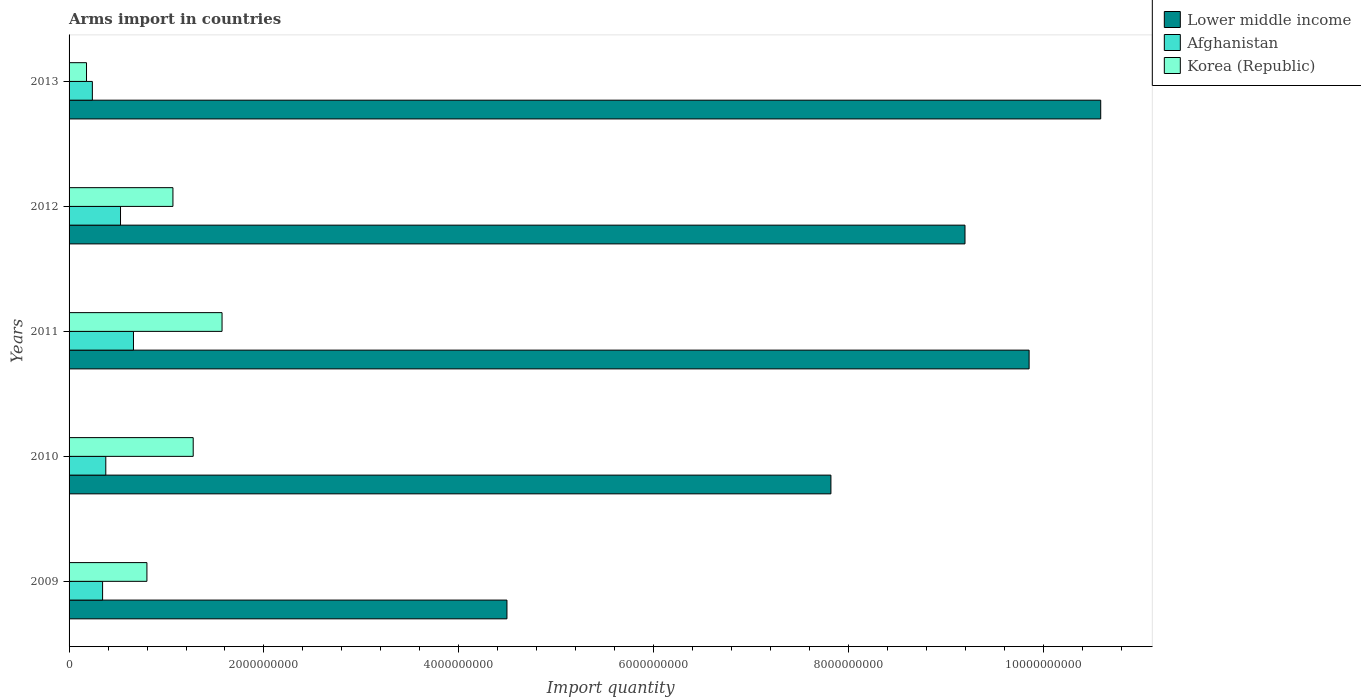How many groups of bars are there?
Keep it short and to the point. 5. Are the number of bars on each tick of the Y-axis equal?
Your answer should be compact. Yes. In how many cases, is the number of bars for a given year not equal to the number of legend labels?
Provide a short and direct response. 0. What is the total arms import in Korea (Republic) in 2010?
Ensure brevity in your answer.  1.27e+09. Across all years, what is the maximum total arms import in Afghanistan?
Make the answer very short. 6.61e+08. Across all years, what is the minimum total arms import in Korea (Republic)?
Offer a terse response. 1.79e+08. In which year was the total arms import in Afghanistan minimum?
Offer a very short reply. 2013. What is the total total arms import in Lower middle income in the graph?
Your answer should be very brief. 4.19e+1. What is the difference between the total arms import in Korea (Republic) in 2010 and that in 2012?
Give a very brief answer. 2.08e+08. What is the difference between the total arms import in Afghanistan in 2010 and the total arms import in Lower middle income in 2013?
Offer a terse response. -1.02e+1. What is the average total arms import in Lower middle income per year?
Your answer should be compact. 8.39e+09. In the year 2012, what is the difference between the total arms import in Lower middle income and total arms import in Afghanistan?
Your answer should be compact. 8.67e+09. What is the ratio of the total arms import in Lower middle income in 2009 to that in 2010?
Make the answer very short. 0.57. What is the difference between the highest and the second highest total arms import in Lower middle income?
Make the answer very short. 7.35e+08. What is the difference between the highest and the lowest total arms import in Afghanistan?
Keep it short and to the point. 4.22e+08. In how many years, is the total arms import in Korea (Republic) greater than the average total arms import in Korea (Republic) taken over all years?
Provide a short and direct response. 3. Is the sum of the total arms import in Korea (Republic) in 2011 and 2013 greater than the maximum total arms import in Lower middle income across all years?
Your answer should be compact. No. What does the 3rd bar from the top in 2010 represents?
Your response must be concise. Lower middle income. What does the 2nd bar from the bottom in 2009 represents?
Make the answer very short. Afghanistan. Is it the case that in every year, the sum of the total arms import in Afghanistan and total arms import in Lower middle income is greater than the total arms import in Korea (Republic)?
Ensure brevity in your answer.  Yes. Does the graph contain grids?
Your answer should be very brief. No. Where does the legend appear in the graph?
Provide a short and direct response. Top right. What is the title of the graph?
Provide a succinct answer. Arms import in countries. What is the label or title of the X-axis?
Ensure brevity in your answer.  Import quantity. What is the Import quantity of Lower middle income in 2009?
Ensure brevity in your answer.  4.49e+09. What is the Import quantity of Afghanistan in 2009?
Provide a succinct answer. 3.44e+08. What is the Import quantity in Korea (Republic) in 2009?
Make the answer very short. 7.99e+08. What is the Import quantity of Lower middle income in 2010?
Your answer should be very brief. 7.82e+09. What is the Import quantity in Afghanistan in 2010?
Provide a short and direct response. 3.77e+08. What is the Import quantity of Korea (Republic) in 2010?
Your response must be concise. 1.27e+09. What is the Import quantity in Lower middle income in 2011?
Ensure brevity in your answer.  9.85e+09. What is the Import quantity of Afghanistan in 2011?
Ensure brevity in your answer.  6.61e+08. What is the Import quantity of Korea (Republic) in 2011?
Ensure brevity in your answer.  1.57e+09. What is the Import quantity of Lower middle income in 2012?
Provide a short and direct response. 9.20e+09. What is the Import quantity of Afghanistan in 2012?
Offer a very short reply. 5.28e+08. What is the Import quantity in Korea (Republic) in 2012?
Provide a short and direct response. 1.07e+09. What is the Import quantity in Lower middle income in 2013?
Ensure brevity in your answer.  1.06e+1. What is the Import quantity in Afghanistan in 2013?
Keep it short and to the point. 2.39e+08. What is the Import quantity of Korea (Republic) in 2013?
Provide a succinct answer. 1.79e+08. Across all years, what is the maximum Import quantity in Lower middle income?
Your answer should be compact. 1.06e+1. Across all years, what is the maximum Import quantity in Afghanistan?
Provide a short and direct response. 6.61e+08. Across all years, what is the maximum Import quantity of Korea (Republic)?
Ensure brevity in your answer.  1.57e+09. Across all years, what is the minimum Import quantity of Lower middle income?
Offer a terse response. 4.49e+09. Across all years, what is the minimum Import quantity of Afghanistan?
Offer a very short reply. 2.39e+08. Across all years, what is the minimum Import quantity of Korea (Republic)?
Provide a short and direct response. 1.79e+08. What is the total Import quantity in Lower middle income in the graph?
Make the answer very short. 4.19e+1. What is the total Import quantity of Afghanistan in the graph?
Your answer should be very brief. 2.15e+09. What is the total Import quantity in Korea (Republic) in the graph?
Provide a short and direct response. 4.89e+09. What is the difference between the Import quantity in Lower middle income in 2009 and that in 2010?
Offer a very short reply. -3.32e+09. What is the difference between the Import quantity in Afghanistan in 2009 and that in 2010?
Give a very brief answer. -3.30e+07. What is the difference between the Import quantity of Korea (Republic) in 2009 and that in 2010?
Provide a short and direct response. -4.75e+08. What is the difference between the Import quantity in Lower middle income in 2009 and that in 2011?
Make the answer very short. -5.36e+09. What is the difference between the Import quantity in Afghanistan in 2009 and that in 2011?
Offer a terse response. -3.17e+08. What is the difference between the Import quantity in Korea (Republic) in 2009 and that in 2011?
Give a very brief answer. -7.71e+08. What is the difference between the Import quantity of Lower middle income in 2009 and that in 2012?
Offer a terse response. -4.70e+09. What is the difference between the Import quantity in Afghanistan in 2009 and that in 2012?
Make the answer very short. -1.84e+08. What is the difference between the Import quantity of Korea (Republic) in 2009 and that in 2012?
Keep it short and to the point. -2.67e+08. What is the difference between the Import quantity of Lower middle income in 2009 and that in 2013?
Provide a succinct answer. -6.09e+09. What is the difference between the Import quantity of Afghanistan in 2009 and that in 2013?
Offer a terse response. 1.05e+08. What is the difference between the Import quantity of Korea (Republic) in 2009 and that in 2013?
Your answer should be very brief. 6.20e+08. What is the difference between the Import quantity in Lower middle income in 2010 and that in 2011?
Make the answer very short. -2.03e+09. What is the difference between the Import quantity in Afghanistan in 2010 and that in 2011?
Keep it short and to the point. -2.84e+08. What is the difference between the Import quantity in Korea (Republic) in 2010 and that in 2011?
Provide a short and direct response. -2.96e+08. What is the difference between the Import quantity in Lower middle income in 2010 and that in 2012?
Your answer should be very brief. -1.38e+09. What is the difference between the Import quantity in Afghanistan in 2010 and that in 2012?
Give a very brief answer. -1.51e+08. What is the difference between the Import quantity of Korea (Republic) in 2010 and that in 2012?
Your answer should be very brief. 2.08e+08. What is the difference between the Import quantity of Lower middle income in 2010 and that in 2013?
Make the answer very short. -2.77e+09. What is the difference between the Import quantity of Afghanistan in 2010 and that in 2013?
Provide a succinct answer. 1.38e+08. What is the difference between the Import quantity of Korea (Republic) in 2010 and that in 2013?
Provide a short and direct response. 1.10e+09. What is the difference between the Import quantity in Lower middle income in 2011 and that in 2012?
Keep it short and to the point. 6.58e+08. What is the difference between the Import quantity in Afghanistan in 2011 and that in 2012?
Your answer should be very brief. 1.33e+08. What is the difference between the Import quantity of Korea (Republic) in 2011 and that in 2012?
Keep it short and to the point. 5.04e+08. What is the difference between the Import quantity of Lower middle income in 2011 and that in 2013?
Offer a very short reply. -7.35e+08. What is the difference between the Import quantity of Afghanistan in 2011 and that in 2013?
Make the answer very short. 4.22e+08. What is the difference between the Import quantity of Korea (Republic) in 2011 and that in 2013?
Provide a short and direct response. 1.39e+09. What is the difference between the Import quantity of Lower middle income in 2012 and that in 2013?
Keep it short and to the point. -1.39e+09. What is the difference between the Import quantity in Afghanistan in 2012 and that in 2013?
Offer a terse response. 2.89e+08. What is the difference between the Import quantity in Korea (Republic) in 2012 and that in 2013?
Ensure brevity in your answer.  8.87e+08. What is the difference between the Import quantity in Lower middle income in 2009 and the Import quantity in Afghanistan in 2010?
Offer a very short reply. 4.12e+09. What is the difference between the Import quantity of Lower middle income in 2009 and the Import quantity of Korea (Republic) in 2010?
Give a very brief answer. 3.22e+09. What is the difference between the Import quantity in Afghanistan in 2009 and the Import quantity in Korea (Republic) in 2010?
Your response must be concise. -9.30e+08. What is the difference between the Import quantity in Lower middle income in 2009 and the Import quantity in Afghanistan in 2011?
Your response must be concise. 3.83e+09. What is the difference between the Import quantity in Lower middle income in 2009 and the Import quantity in Korea (Republic) in 2011?
Provide a succinct answer. 2.92e+09. What is the difference between the Import quantity in Afghanistan in 2009 and the Import quantity in Korea (Republic) in 2011?
Your answer should be compact. -1.23e+09. What is the difference between the Import quantity of Lower middle income in 2009 and the Import quantity of Afghanistan in 2012?
Your answer should be compact. 3.97e+09. What is the difference between the Import quantity of Lower middle income in 2009 and the Import quantity of Korea (Republic) in 2012?
Ensure brevity in your answer.  3.43e+09. What is the difference between the Import quantity in Afghanistan in 2009 and the Import quantity in Korea (Republic) in 2012?
Give a very brief answer. -7.22e+08. What is the difference between the Import quantity of Lower middle income in 2009 and the Import quantity of Afghanistan in 2013?
Your answer should be compact. 4.26e+09. What is the difference between the Import quantity in Lower middle income in 2009 and the Import quantity in Korea (Republic) in 2013?
Keep it short and to the point. 4.32e+09. What is the difference between the Import quantity in Afghanistan in 2009 and the Import quantity in Korea (Republic) in 2013?
Your answer should be very brief. 1.65e+08. What is the difference between the Import quantity of Lower middle income in 2010 and the Import quantity of Afghanistan in 2011?
Your answer should be very brief. 7.16e+09. What is the difference between the Import quantity in Lower middle income in 2010 and the Import quantity in Korea (Republic) in 2011?
Keep it short and to the point. 6.25e+09. What is the difference between the Import quantity in Afghanistan in 2010 and the Import quantity in Korea (Republic) in 2011?
Ensure brevity in your answer.  -1.19e+09. What is the difference between the Import quantity of Lower middle income in 2010 and the Import quantity of Afghanistan in 2012?
Make the answer very short. 7.29e+09. What is the difference between the Import quantity of Lower middle income in 2010 and the Import quantity of Korea (Republic) in 2012?
Provide a succinct answer. 6.75e+09. What is the difference between the Import quantity in Afghanistan in 2010 and the Import quantity in Korea (Republic) in 2012?
Your answer should be compact. -6.89e+08. What is the difference between the Import quantity of Lower middle income in 2010 and the Import quantity of Afghanistan in 2013?
Offer a very short reply. 7.58e+09. What is the difference between the Import quantity of Lower middle income in 2010 and the Import quantity of Korea (Republic) in 2013?
Your answer should be compact. 7.64e+09. What is the difference between the Import quantity in Afghanistan in 2010 and the Import quantity in Korea (Republic) in 2013?
Make the answer very short. 1.98e+08. What is the difference between the Import quantity of Lower middle income in 2011 and the Import quantity of Afghanistan in 2012?
Your answer should be compact. 9.32e+09. What is the difference between the Import quantity of Lower middle income in 2011 and the Import quantity of Korea (Republic) in 2012?
Offer a very short reply. 8.79e+09. What is the difference between the Import quantity in Afghanistan in 2011 and the Import quantity in Korea (Republic) in 2012?
Give a very brief answer. -4.05e+08. What is the difference between the Import quantity in Lower middle income in 2011 and the Import quantity in Afghanistan in 2013?
Make the answer very short. 9.61e+09. What is the difference between the Import quantity of Lower middle income in 2011 and the Import quantity of Korea (Republic) in 2013?
Ensure brevity in your answer.  9.67e+09. What is the difference between the Import quantity of Afghanistan in 2011 and the Import quantity of Korea (Republic) in 2013?
Give a very brief answer. 4.82e+08. What is the difference between the Import quantity of Lower middle income in 2012 and the Import quantity of Afghanistan in 2013?
Your response must be concise. 8.96e+09. What is the difference between the Import quantity in Lower middle income in 2012 and the Import quantity in Korea (Republic) in 2013?
Offer a very short reply. 9.02e+09. What is the difference between the Import quantity in Afghanistan in 2012 and the Import quantity in Korea (Republic) in 2013?
Offer a very short reply. 3.49e+08. What is the average Import quantity of Lower middle income per year?
Offer a terse response. 8.39e+09. What is the average Import quantity in Afghanistan per year?
Your response must be concise. 4.30e+08. What is the average Import quantity of Korea (Republic) per year?
Keep it short and to the point. 9.78e+08. In the year 2009, what is the difference between the Import quantity of Lower middle income and Import quantity of Afghanistan?
Your answer should be very brief. 4.15e+09. In the year 2009, what is the difference between the Import quantity in Lower middle income and Import quantity in Korea (Republic)?
Ensure brevity in your answer.  3.70e+09. In the year 2009, what is the difference between the Import quantity in Afghanistan and Import quantity in Korea (Republic)?
Keep it short and to the point. -4.55e+08. In the year 2010, what is the difference between the Import quantity of Lower middle income and Import quantity of Afghanistan?
Provide a short and direct response. 7.44e+09. In the year 2010, what is the difference between the Import quantity in Lower middle income and Import quantity in Korea (Republic)?
Provide a short and direct response. 6.54e+09. In the year 2010, what is the difference between the Import quantity of Afghanistan and Import quantity of Korea (Republic)?
Your answer should be compact. -8.97e+08. In the year 2011, what is the difference between the Import quantity in Lower middle income and Import quantity in Afghanistan?
Make the answer very short. 9.19e+09. In the year 2011, what is the difference between the Import quantity of Lower middle income and Import quantity of Korea (Republic)?
Provide a short and direct response. 8.28e+09. In the year 2011, what is the difference between the Import quantity of Afghanistan and Import quantity of Korea (Republic)?
Ensure brevity in your answer.  -9.09e+08. In the year 2012, what is the difference between the Import quantity in Lower middle income and Import quantity in Afghanistan?
Offer a very short reply. 8.67e+09. In the year 2012, what is the difference between the Import quantity of Lower middle income and Import quantity of Korea (Republic)?
Keep it short and to the point. 8.13e+09. In the year 2012, what is the difference between the Import quantity in Afghanistan and Import quantity in Korea (Republic)?
Your answer should be very brief. -5.38e+08. In the year 2013, what is the difference between the Import quantity in Lower middle income and Import quantity in Afghanistan?
Ensure brevity in your answer.  1.03e+1. In the year 2013, what is the difference between the Import quantity of Lower middle income and Import quantity of Korea (Republic)?
Make the answer very short. 1.04e+1. In the year 2013, what is the difference between the Import quantity in Afghanistan and Import quantity in Korea (Republic)?
Ensure brevity in your answer.  6.00e+07. What is the ratio of the Import quantity of Lower middle income in 2009 to that in 2010?
Give a very brief answer. 0.57. What is the ratio of the Import quantity of Afghanistan in 2009 to that in 2010?
Ensure brevity in your answer.  0.91. What is the ratio of the Import quantity of Korea (Republic) in 2009 to that in 2010?
Your response must be concise. 0.63. What is the ratio of the Import quantity in Lower middle income in 2009 to that in 2011?
Ensure brevity in your answer.  0.46. What is the ratio of the Import quantity of Afghanistan in 2009 to that in 2011?
Your answer should be very brief. 0.52. What is the ratio of the Import quantity in Korea (Republic) in 2009 to that in 2011?
Your answer should be compact. 0.51. What is the ratio of the Import quantity in Lower middle income in 2009 to that in 2012?
Offer a terse response. 0.49. What is the ratio of the Import quantity of Afghanistan in 2009 to that in 2012?
Give a very brief answer. 0.65. What is the ratio of the Import quantity in Korea (Republic) in 2009 to that in 2012?
Your answer should be very brief. 0.75. What is the ratio of the Import quantity of Lower middle income in 2009 to that in 2013?
Offer a terse response. 0.42. What is the ratio of the Import quantity in Afghanistan in 2009 to that in 2013?
Make the answer very short. 1.44. What is the ratio of the Import quantity in Korea (Republic) in 2009 to that in 2013?
Provide a short and direct response. 4.46. What is the ratio of the Import quantity in Lower middle income in 2010 to that in 2011?
Your response must be concise. 0.79. What is the ratio of the Import quantity of Afghanistan in 2010 to that in 2011?
Your answer should be very brief. 0.57. What is the ratio of the Import quantity in Korea (Republic) in 2010 to that in 2011?
Your answer should be very brief. 0.81. What is the ratio of the Import quantity in Lower middle income in 2010 to that in 2012?
Keep it short and to the point. 0.85. What is the ratio of the Import quantity in Afghanistan in 2010 to that in 2012?
Your response must be concise. 0.71. What is the ratio of the Import quantity in Korea (Republic) in 2010 to that in 2012?
Offer a terse response. 1.2. What is the ratio of the Import quantity of Lower middle income in 2010 to that in 2013?
Your response must be concise. 0.74. What is the ratio of the Import quantity in Afghanistan in 2010 to that in 2013?
Your answer should be compact. 1.58. What is the ratio of the Import quantity of Korea (Republic) in 2010 to that in 2013?
Offer a terse response. 7.12. What is the ratio of the Import quantity in Lower middle income in 2011 to that in 2012?
Offer a terse response. 1.07. What is the ratio of the Import quantity in Afghanistan in 2011 to that in 2012?
Your answer should be very brief. 1.25. What is the ratio of the Import quantity in Korea (Republic) in 2011 to that in 2012?
Provide a short and direct response. 1.47. What is the ratio of the Import quantity of Lower middle income in 2011 to that in 2013?
Make the answer very short. 0.93. What is the ratio of the Import quantity in Afghanistan in 2011 to that in 2013?
Offer a terse response. 2.77. What is the ratio of the Import quantity of Korea (Republic) in 2011 to that in 2013?
Provide a short and direct response. 8.77. What is the ratio of the Import quantity of Lower middle income in 2012 to that in 2013?
Your answer should be compact. 0.87. What is the ratio of the Import quantity of Afghanistan in 2012 to that in 2013?
Your response must be concise. 2.21. What is the ratio of the Import quantity of Korea (Republic) in 2012 to that in 2013?
Give a very brief answer. 5.96. What is the difference between the highest and the second highest Import quantity in Lower middle income?
Offer a very short reply. 7.35e+08. What is the difference between the highest and the second highest Import quantity of Afghanistan?
Ensure brevity in your answer.  1.33e+08. What is the difference between the highest and the second highest Import quantity in Korea (Republic)?
Offer a very short reply. 2.96e+08. What is the difference between the highest and the lowest Import quantity of Lower middle income?
Offer a terse response. 6.09e+09. What is the difference between the highest and the lowest Import quantity in Afghanistan?
Make the answer very short. 4.22e+08. What is the difference between the highest and the lowest Import quantity of Korea (Republic)?
Provide a succinct answer. 1.39e+09. 